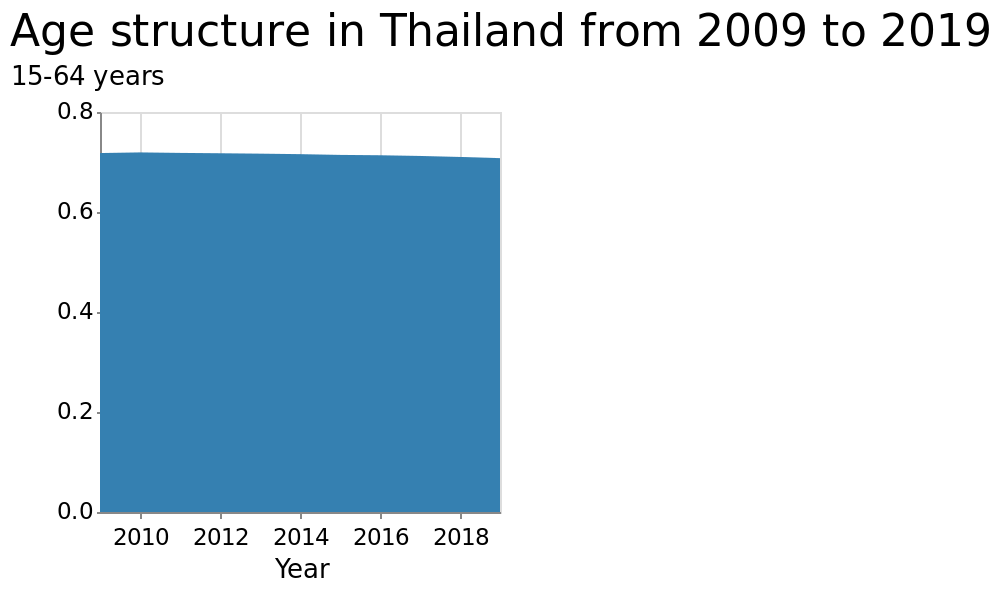<image>
What has been the trend in the age structure from 2009 to 2019? The age structure has mildly decreased over this time period. please describe the details of the chart Here a is a area diagram titled Age structure in Thailand from 2009 to 2019. On the y-axis, 15-64 years is measured. Year is defined on a linear scale with a minimum of 2010 and a maximum of 2018 along the x-axis. What is the title of the area diagram?  The title of the area diagram is "Age structure in Thailand from 2009 to 2019." please summary the statistics and relations of the chart The age structure has only decreased very mildly over the years 2009 to 2019. It has been a consistent decrease though at a steady rate. What is measured on the y-axis?  The y-axis measures the age group 15-64 years. Has the age structure consistently decreased from 2009 to 2019? Yes, the age structure has consistently decreased over this time period. 